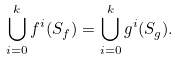Convert formula to latex. <formula><loc_0><loc_0><loc_500><loc_500>\bigcup _ { i = 0 } ^ { k } f ^ { i } ( S _ { f } ) = \bigcup _ { i = 0 } ^ { k } g ^ { i } ( S _ { g } ) .</formula> 